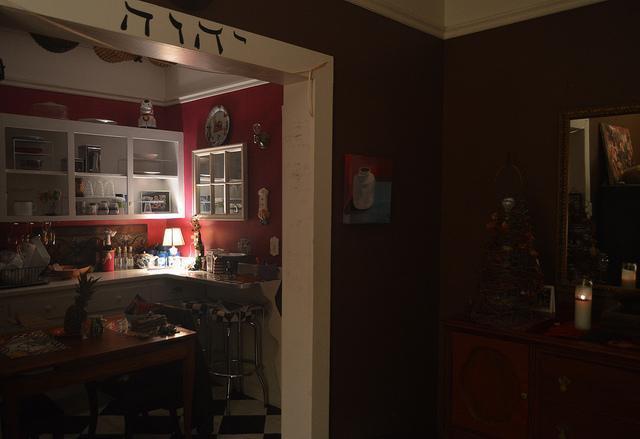How many chairs are there?
Give a very brief answer. 2. How many people are eating in this photo?
Give a very brief answer. 0. 